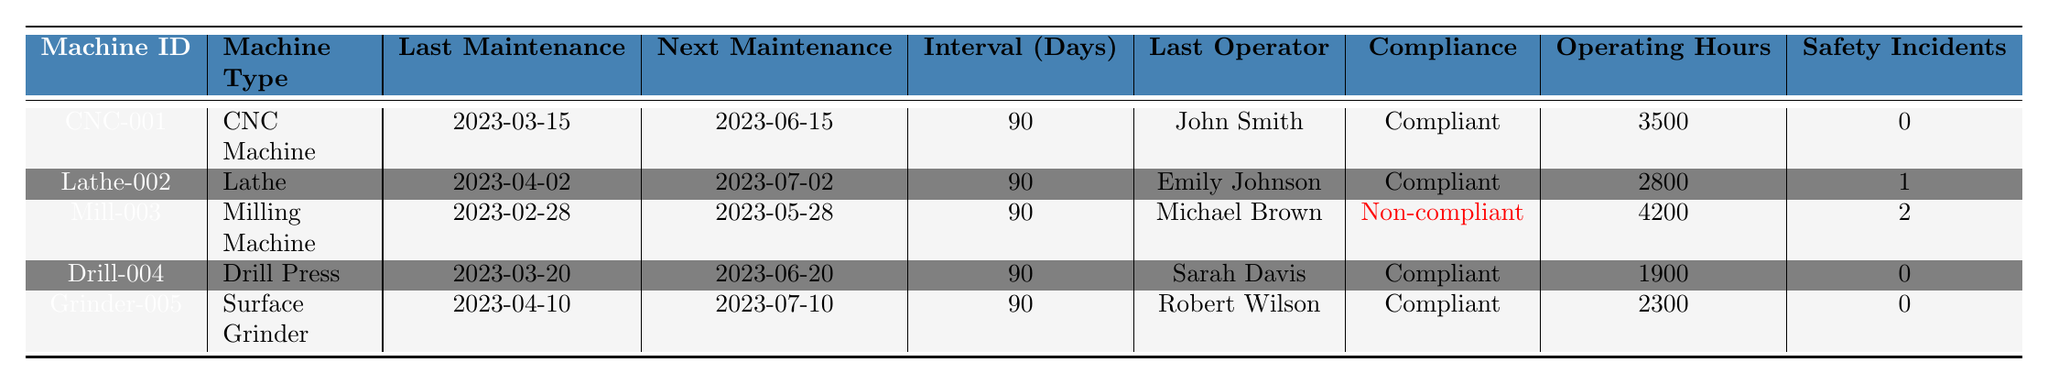What is the next scheduled maintenance date for the CNC Machine? The next scheduled maintenance for CNC Machine (CNC-001) is listed in the table under "Next Maintenance," which shows 2023-06-15.
Answer: 2023-06-15 Which machine has the highest total operating hours? The total operating hours for each machine are provided in the "Operating Hours" column. By comparing the values, the Milling Machine (Mill-003) has the highest total operating hours at 4200.
Answer: Mill-003 Is the last operator for the Lathe compliant? The compliance status for the Lathe (Lathe-002) is "Compliant," as recorded in the table. Therefore, the last operator is compliant.
Answer: Yes How many safety incidents have occurred for the Milling Machine? The table shows 2 safety incidents reported for the Milling Machine (Mill-003) in the "Safety Incidents" column.
Answer: 2 What is the average maintenance cost for all machines? The maintenance costs for the five machines are 1200.50, 950.75, 1500.25, 750.00, and 1100.00. Summing these yields 4501.50, and dividing by 5 gives an average of 900.30.
Answer: 900.30 Which machine is non-compliant and how many days has it been since its last maintenance? The table indicates that the Milling Machine (Mill-003) is non-compliant, and the "Days Since Last Maintenance" column shows it has been 61 days since the last maintenance.
Answer: Mill-003, 61 days What is the difference in days since last maintenance between the CNC Machine and the Grinder? The days since last maintenance for CNC Machine (CNC-001) is 46 days, and for Grinder (Grinder-005) it is 20 days. The difference is 46 - 20 = 26 days.
Answer: 26 days How many machines are operated by certified operators? The "Operator Certifications Up to Date" column indicates that four out of five operators are certified (CNC-001, Lathe-002, Drill-004, Grinder-005). Therefore, 4 machines have certified operators.
Answer: 4 machines What is the total maintenance cost for compliant machines only? The compliant machines are CNC Machine (1200.50), Lathe (950.75), Drill Press (750.00), and Surface Grinder (1100.00). Adding these costs gives a total of 1200.50 + 950.75 + 750.00 + 1100.00 = 3001.25.
Answer: 3001.25 If the maintenance interval is 90 days, how many days until the next maintenance for the non-compliant machine? The next scheduled maintenance for the non-compliant machine (Mill-003) is on 2023-05-28. From today, which is 2023-04-10, it is 48 days until the next maintenance.
Answer: 48 days 